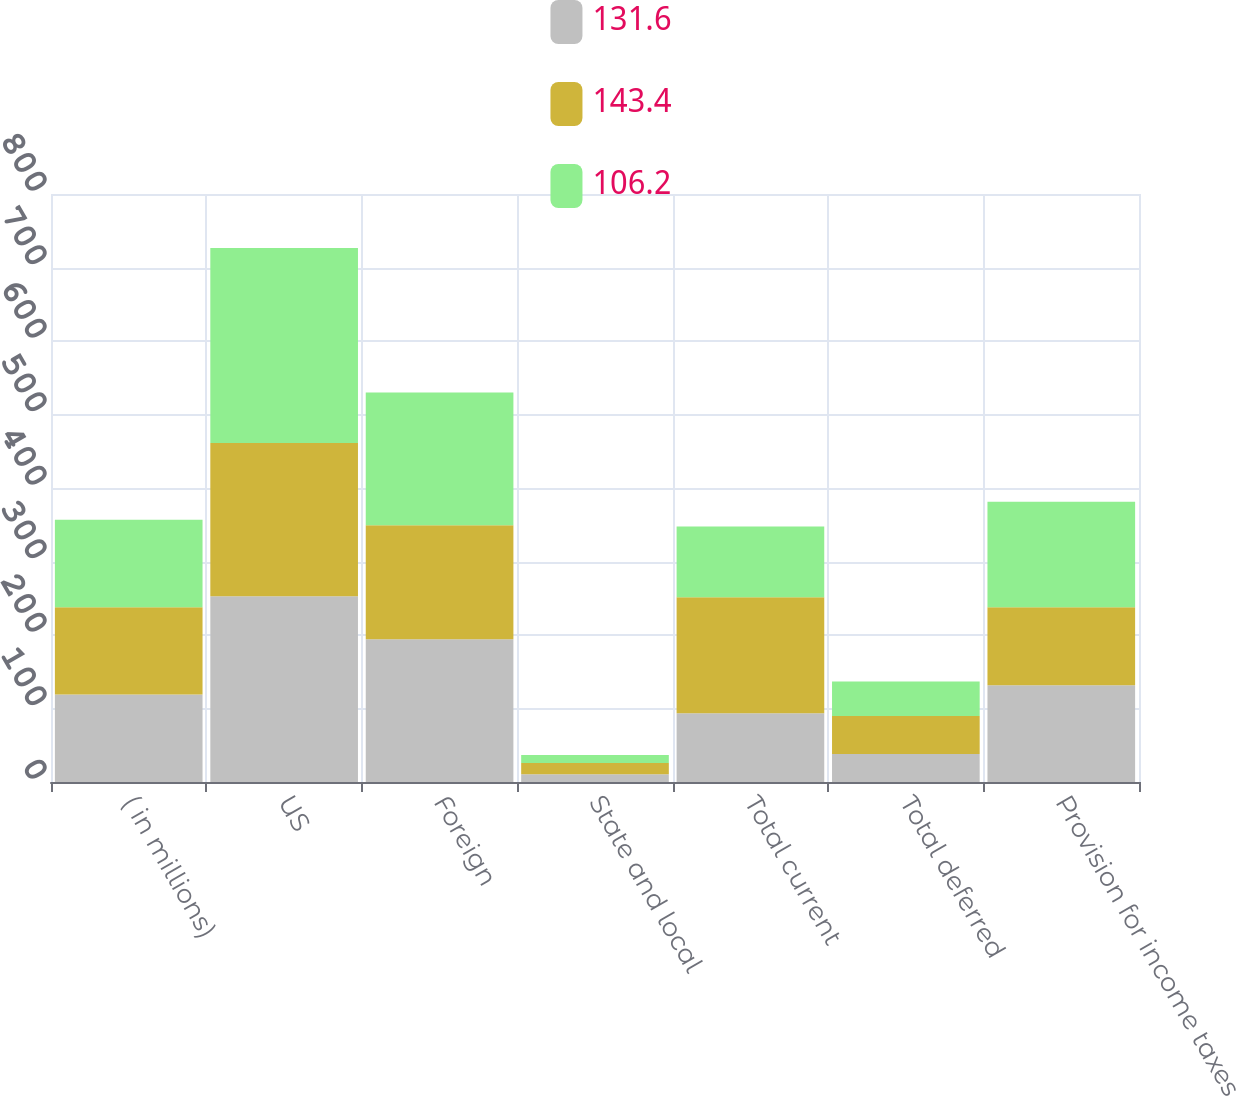<chart> <loc_0><loc_0><loc_500><loc_500><stacked_bar_chart><ecel><fcel>( in millions)<fcel>US<fcel>Foreign<fcel>State and local<fcel>Total current<fcel>Total deferred<fcel>Provision for income taxes<nl><fcel>131.6<fcel>118.9<fcel>252.6<fcel>194.3<fcel>10.7<fcel>93.4<fcel>38.2<fcel>131.6<nl><fcel>143.4<fcel>118.9<fcel>208.5<fcel>155.1<fcel>15.3<fcel>157.8<fcel>51.6<fcel>106.2<nl><fcel>106.2<fcel>118.9<fcel>265.5<fcel>180.4<fcel>10.6<fcel>96.4<fcel>47<fcel>143.4<nl></chart> 